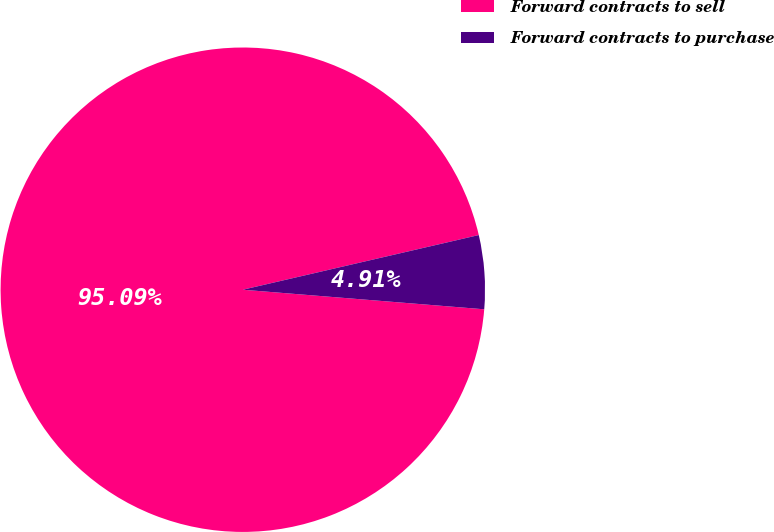Convert chart. <chart><loc_0><loc_0><loc_500><loc_500><pie_chart><fcel>Forward contracts to sell<fcel>Forward contracts to purchase<nl><fcel>95.09%<fcel>4.91%<nl></chart> 